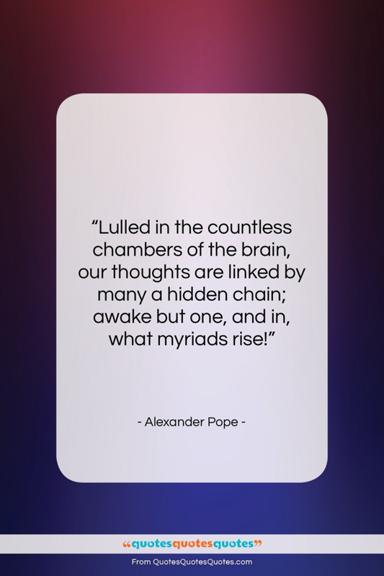What is the color scheme of the image? Upon closer observation, the image features a gradient background that seamlessly transitions from a deep, saturated violet at the top to a softer, muted blue towards the bottom. This creates a calming and contemplative atmosphere around the central white card displaying the quote, drawing the viewer's focus to the text. The gradient is subtly complex, with smooth variations in hue and saturation, enhancing the visual appeal of the message being conveyed. 